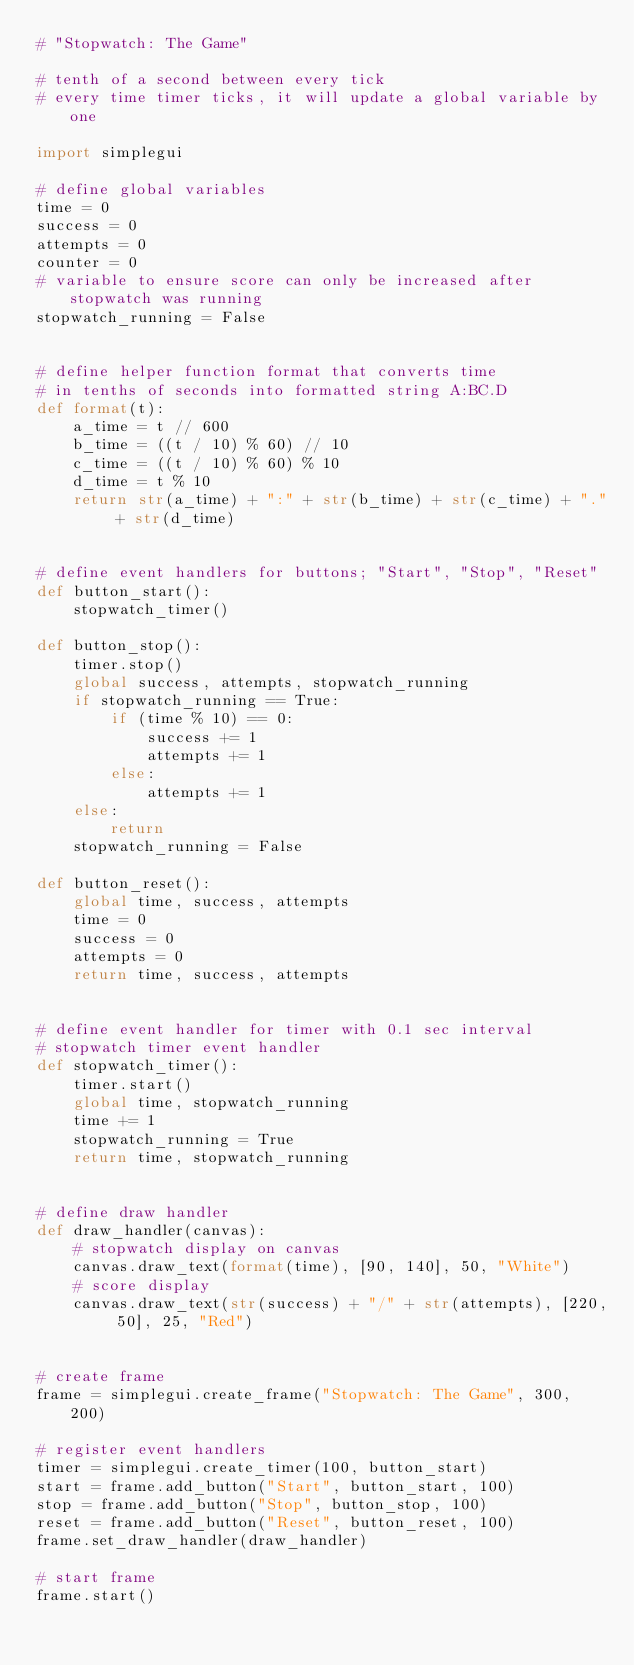Convert code to text. <code><loc_0><loc_0><loc_500><loc_500><_Python_># "Stopwatch: The Game"

# tenth of a second between every tick
# every time timer ticks, it will update a global variable by one

import simplegui

# define global variables
time = 0
success = 0
attempts = 0
counter = 0
# variable to ensure score can only be increased after stopwatch was running
stopwatch_running = False


# define helper function format that converts time
# in tenths of seconds into formatted string A:BC.D
def format(t):
    a_time = t // 600
    b_time = ((t / 10) % 60) // 10
    c_time = ((t / 10) % 60) % 10
    d_time = t % 10
    return str(a_time) + ":" + str(b_time) + str(c_time) + "." + str(d_time)


# define event handlers for buttons; "Start", "Stop", "Reset"
def button_start():
    stopwatch_timer()

def button_stop():
    timer.stop()
    global success, attempts, stopwatch_running
    if stopwatch_running == True:
        if (time % 10) == 0:
            success += 1
            attempts += 1
        else:
            attempts += 1
    else:
        return        
    stopwatch_running = False
    
def button_reset():
    global time, success, attempts
    time = 0
    success = 0
    attempts = 0
    return time, success, attempts


# define event handler for timer with 0.1 sec interval
# stopwatch timer event handler
def stopwatch_timer():
    timer.start()
    global time, stopwatch_running
    time += 1
    stopwatch_running = True
    return time, stopwatch_running
    

# define draw handler
def draw_handler(canvas):
    # stopwatch display on canvas
    canvas.draw_text(format(time), [90, 140], 50, "White")
    # score display
    canvas.draw_text(str(success) + "/" + str(attempts), [220, 50], 25, "Red")

    
# create frame
frame = simplegui.create_frame("Stopwatch: The Game", 300, 200)

# register event handlers
timer = simplegui.create_timer(100, button_start)
start = frame.add_button("Start", button_start, 100)
stop = frame.add_button("Stop", button_stop, 100)
reset = frame.add_button("Reset", button_reset, 100)
frame.set_draw_handler(draw_handler)

# start frame
frame.start()
</code> 